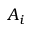Convert formula to latex. <formula><loc_0><loc_0><loc_500><loc_500>A _ { i }</formula> 